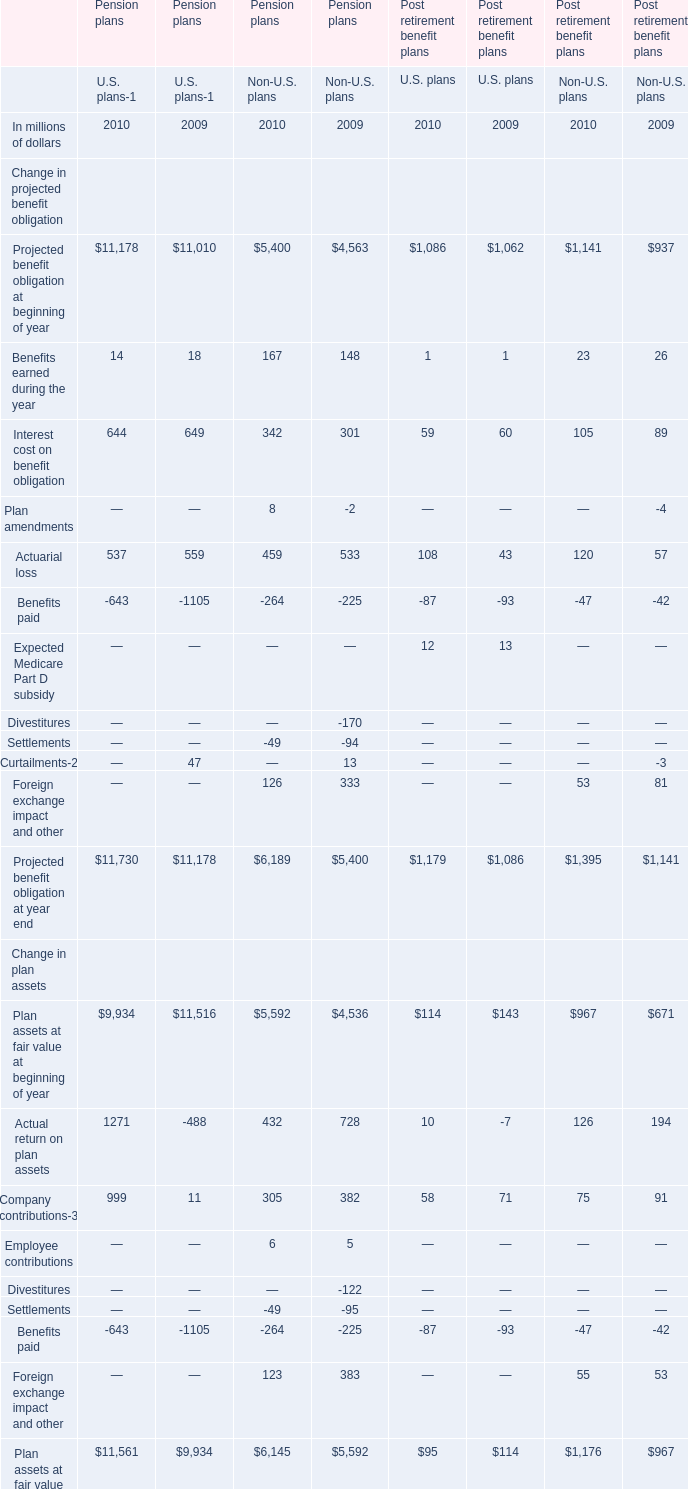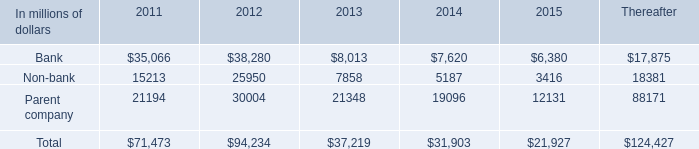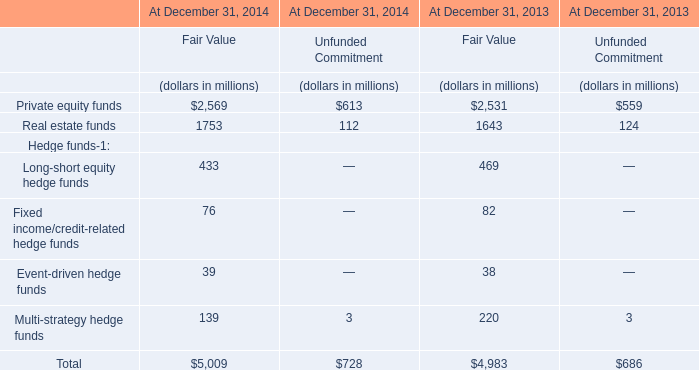What's the sum of all Benefits earned during the year that are greater than 100 in 2010? (in million) 
Answer: 167. 